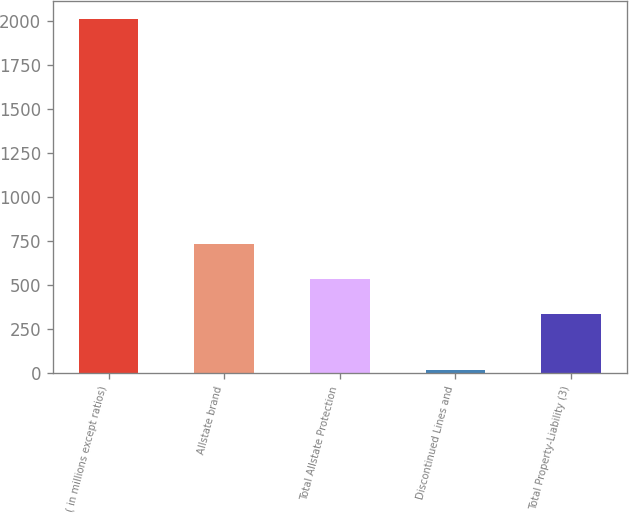Convert chart to OTSL. <chart><loc_0><loc_0><loc_500><loc_500><bar_chart><fcel>( in millions except ratios)<fcel>Allstate brand<fcel>Total Allstate Protection<fcel>Discontinued Lines and<fcel>Total Property-Liability (3)<nl><fcel>2011<fcel>733<fcel>534<fcel>21<fcel>335<nl></chart> 